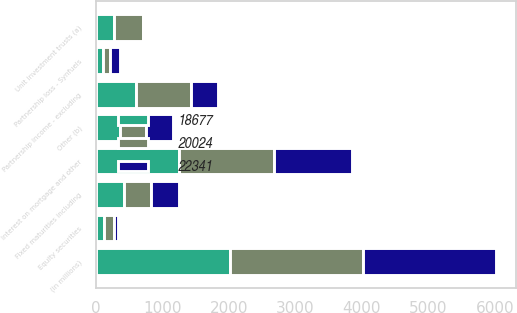Convert chart. <chart><loc_0><loc_0><loc_500><loc_500><stacked_bar_chart><ecel><fcel>(in millions)<fcel>Fixed maturities including<fcel>Equity securities<fcel>Interest on mortgage and other<fcel>Partnership income - excluding<fcel>Partnership loss - Synfuels<fcel>Unit investment trusts (a)<fcel>Other (b)<nl><fcel>20024<fcel>2007<fcel>413<fcel>161<fcel>1423<fcel>823<fcel>101<fcel>442<fcel>394<nl><fcel>18677<fcel>2006<fcel>413<fcel>112<fcel>1252<fcel>599<fcel>107<fcel>264<fcel>350<nl><fcel>22341<fcel>2005<fcel>413<fcel>61<fcel>1175<fcel>416<fcel>143<fcel>4<fcel>413<nl></chart> 